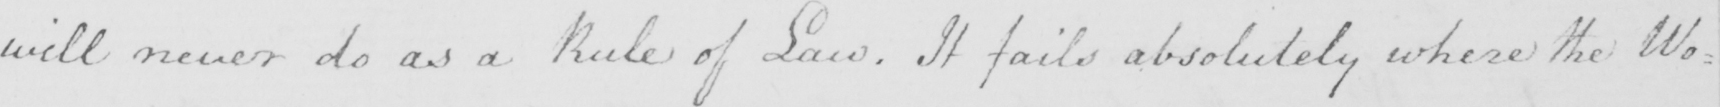Please provide the text content of this handwritten line. will never do as a Rule of Law . It fails absolutely where the Wo : 